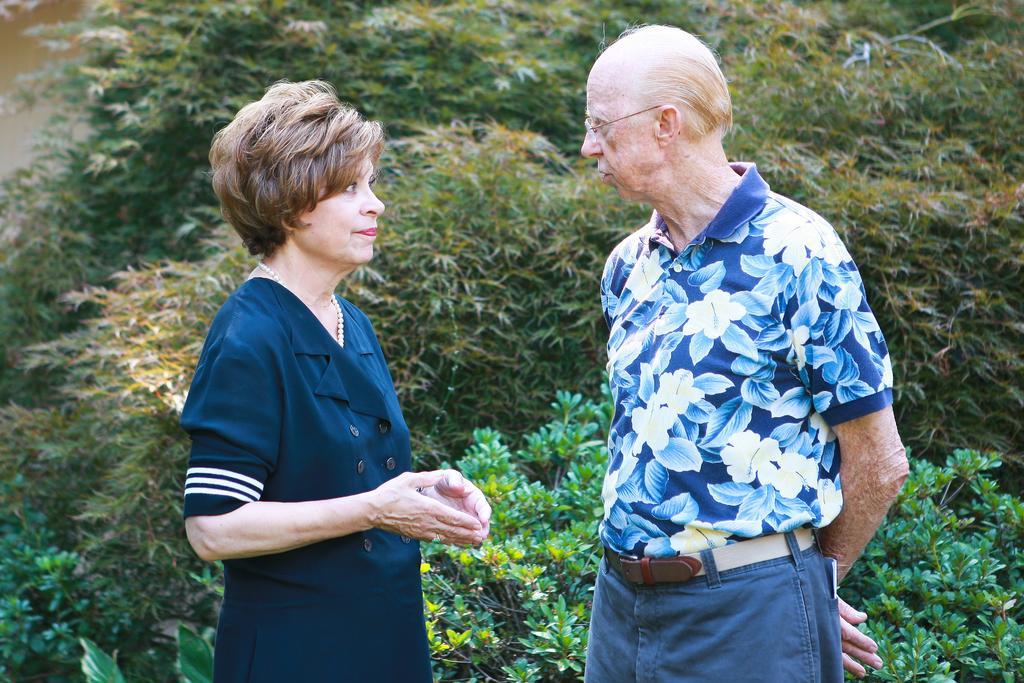Can you describe this image briefly? In this image, we can see a woman and man are looking at each other. They are standing. Background we can see plants. 